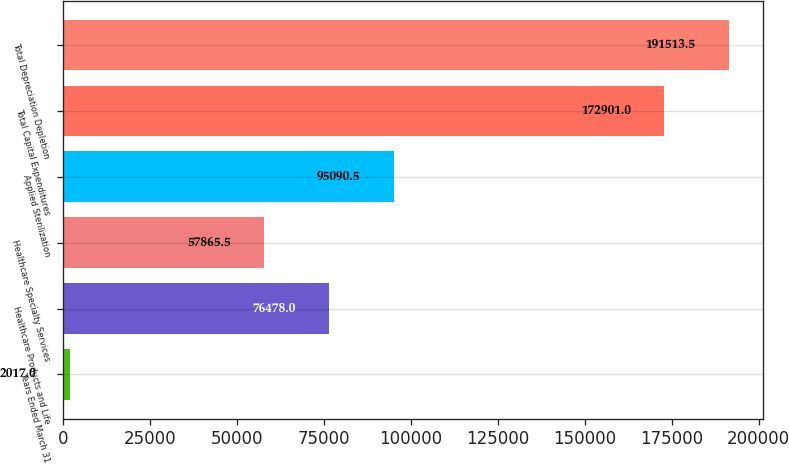Convert chart. <chart><loc_0><loc_0><loc_500><loc_500><bar_chart><fcel>Years Ended March 31<fcel>Healthcare Products and Life<fcel>Healthcare Specialty Services<fcel>Applied Sterilization<fcel>Total Capital Expenditures<fcel>Total Depreciation Depletion<nl><fcel>2017<fcel>76478<fcel>57865.5<fcel>95090.5<fcel>172901<fcel>191514<nl></chart> 